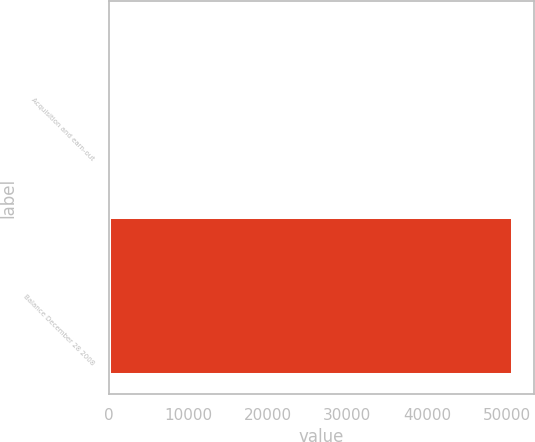<chart> <loc_0><loc_0><loc_500><loc_500><bar_chart><fcel>Acquisition and earn-out<fcel>Balance December 28 2008<nl><fcel>591<fcel>50850<nl></chart> 